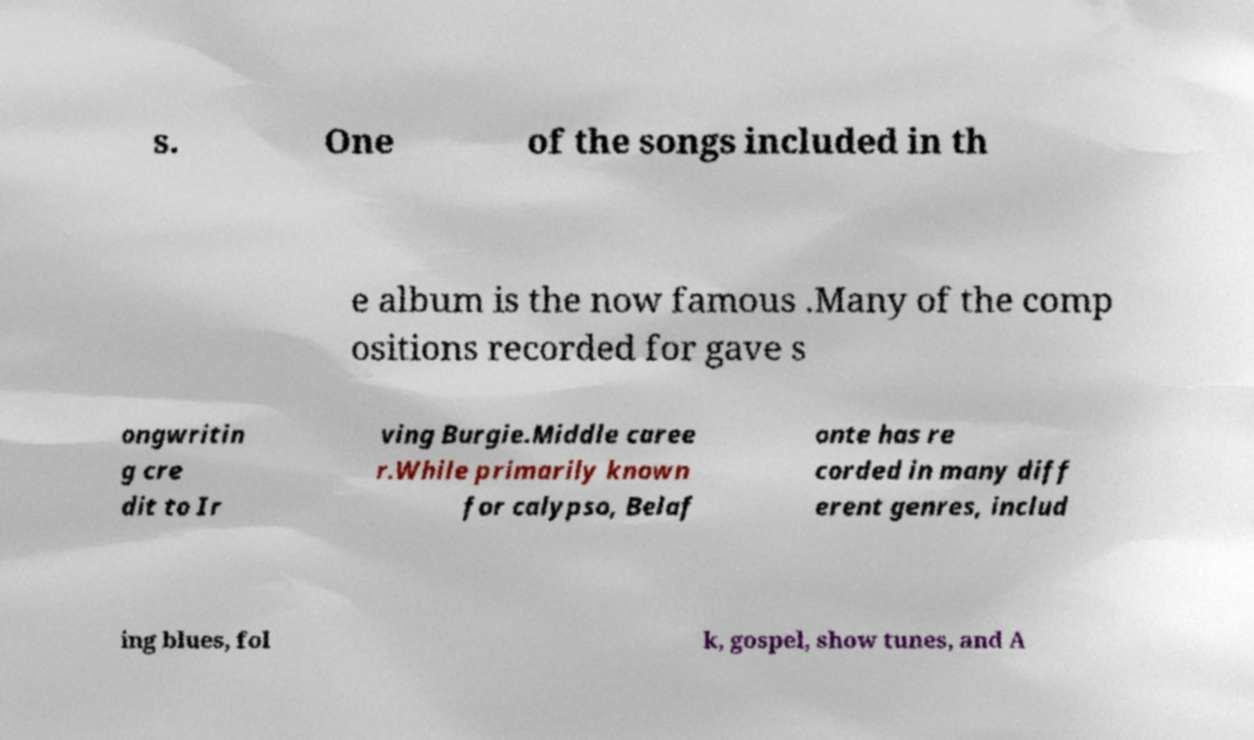For documentation purposes, I need the text within this image transcribed. Could you provide that? s. One of the songs included in th e album is the now famous .Many of the comp ositions recorded for gave s ongwritin g cre dit to Ir ving Burgie.Middle caree r.While primarily known for calypso, Belaf onte has re corded in many diff erent genres, includ ing blues, fol k, gospel, show tunes, and A 